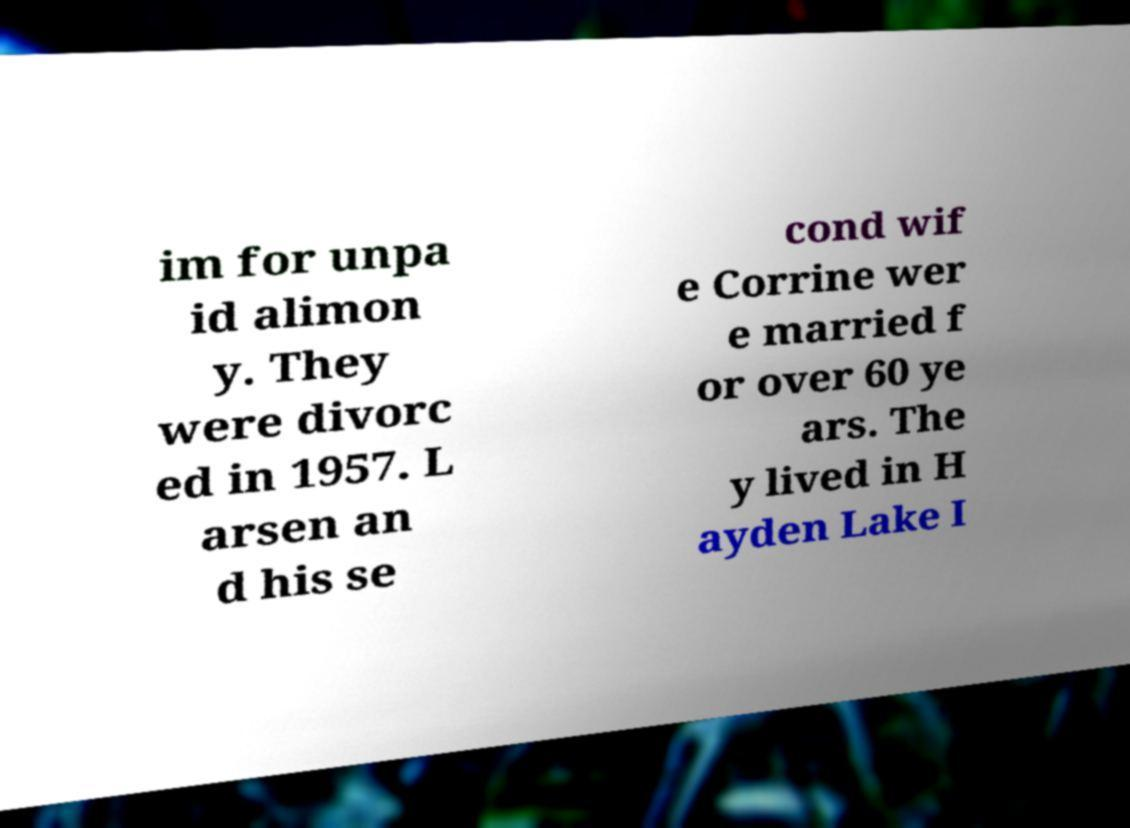Could you extract and type out the text from this image? im for unpa id alimon y. They were divorc ed in 1957. L arsen an d his se cond wif e Corrine wer e married f or over 60 ye ars. The y lived in H ayden Lake I 